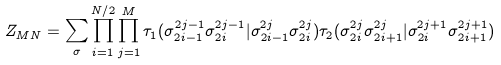<formula> <loc_0><loc_0><loc_500><loc_500>Z _ { M N } = \sum _ { \sigma } \prod _ { i = 1 } ^ { N / 2 } \prod _ { j = 1 } ^ { M } \tau _ { 1 } ( \sigma _ { 2 i - 1 } ^ { 2 j - 1 } \sigma _ { 2 i } ^ { 2 j - 1 } | \sigma _ { 2 i - 1 } ^ { 2 j } \sigma _ { 2 i } ^ { 2 j } ) \tau _ { 2 } ( \sigma _ { 2 i } ^ { 2 j } \sigma _ { 2 i + 1 } ^ { 2 j } | \sigma _ { 2 i } ^ { 2 j + 1 } \sigma _ { 2 i + 1 } ^ { 2 j + 1 } )</formula> 